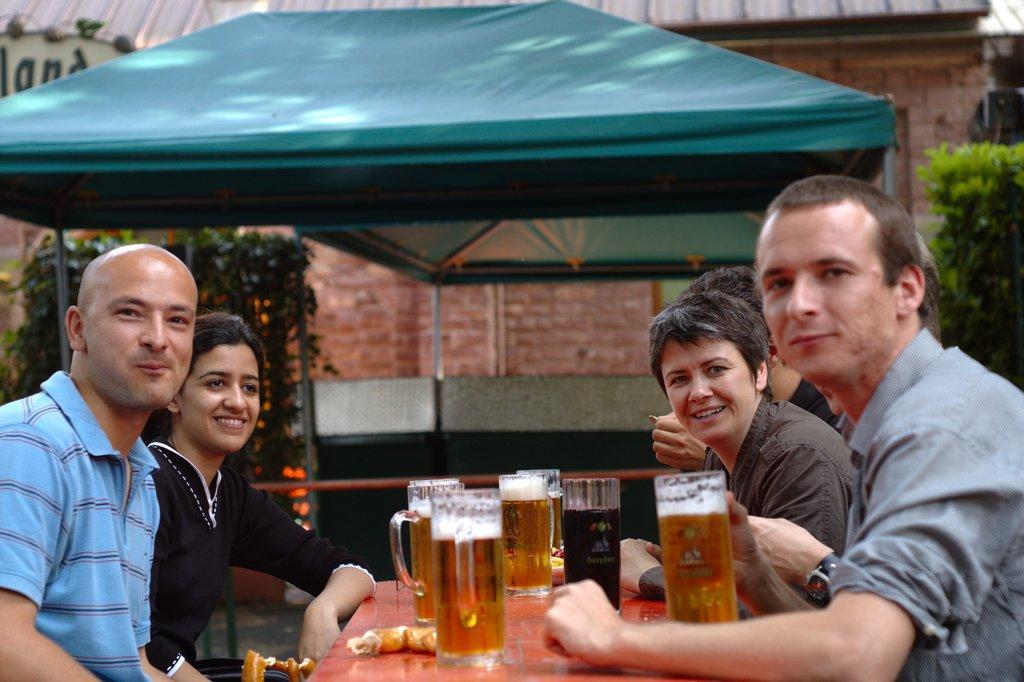Please provide a concise description of this image. In this picture there are group of people those who are sitting around the table, there are cool drink glasses on the table and there are some trees around the area of the image and there is a building at the center of the image. 